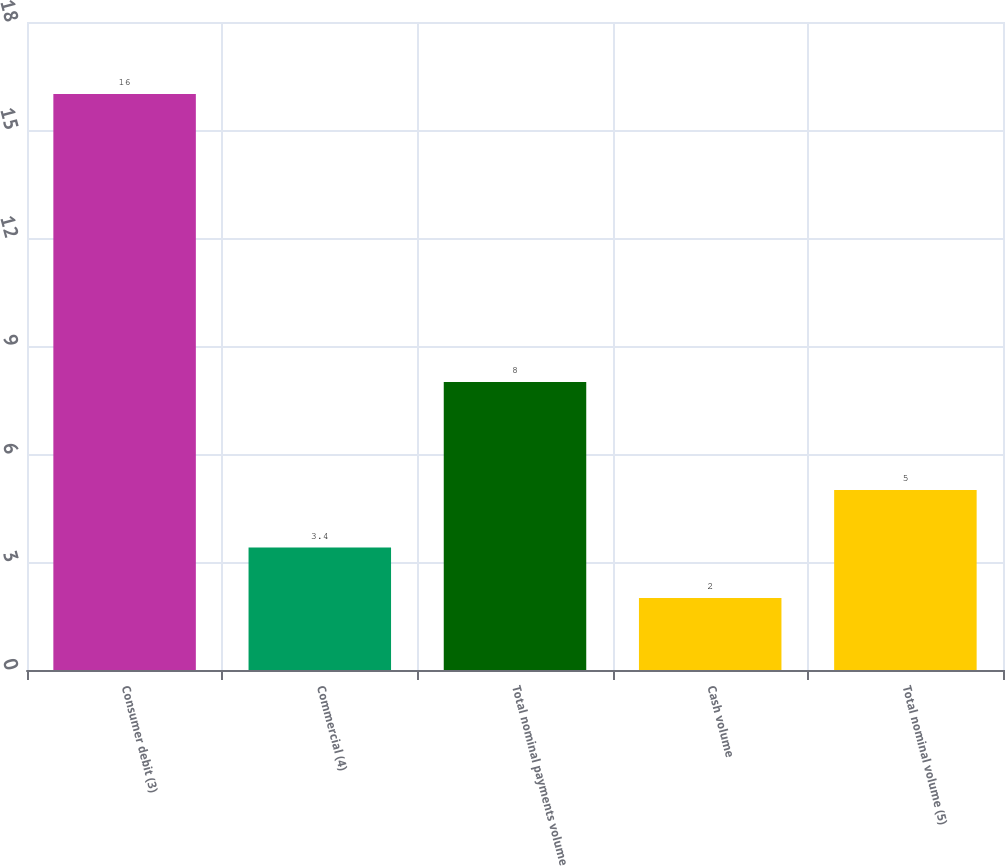<chart> <loc_0><loc_0><loc_500><loc_500><bar_chart><fcel>Consumer debit (3)<fcel>Commercial (4)<fcel>Total nominal payments volume<fcel>Cash volume<fcel>Total nominal volume (5)<nl><fcel>16<fcel>3.4<fcel>8<fcel>2<fcel>5<nl></chart> 